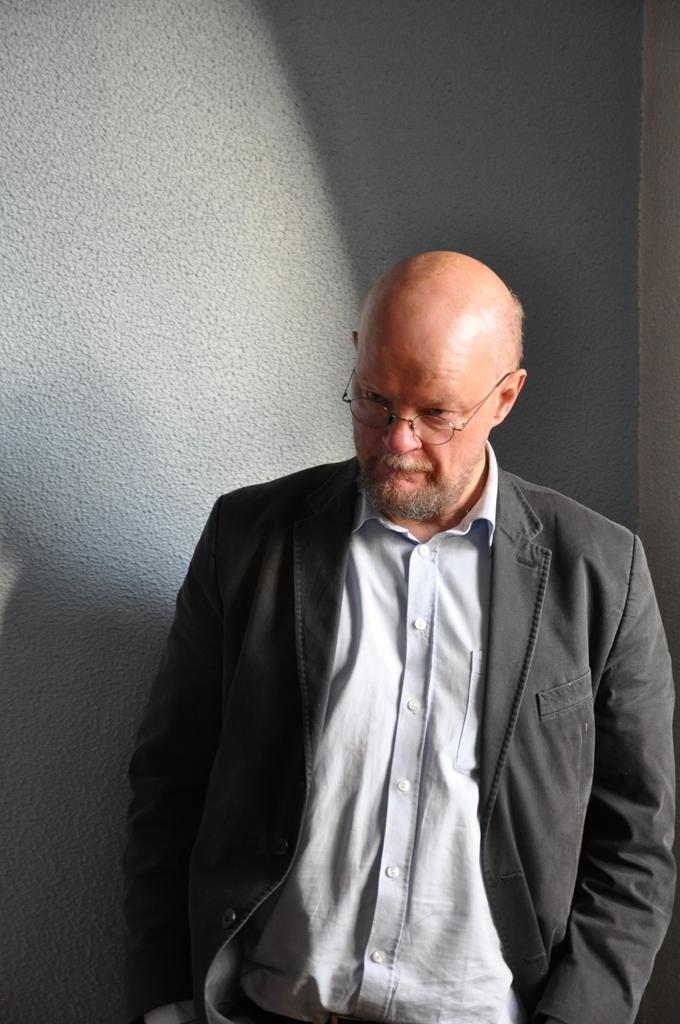Who is present in the image? There is a man in the image. What is the man doing in the image? The man is standing. What is the man wearing on his upper body? The man is wearing a shirt and a black jacket. What accessory is the man wearing in the image? The man is wearing specs. What can be seen in the background of the image? There are shadows on the wall in the background of the image. How many family members are present in the image? There is no family present in the image; it only features a man. What type of friction is visible between the man and the wall in the image? There is no friction visible between the man and the wall in the image. 